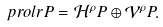<formula> <loc_0><loc_0><loc_500><loc_500>\ p r o l r { P } = { \mathcal { H } } ^ { \rho } P \oplus { \mathcal { V } } ^ { \rho } P .</formula> 